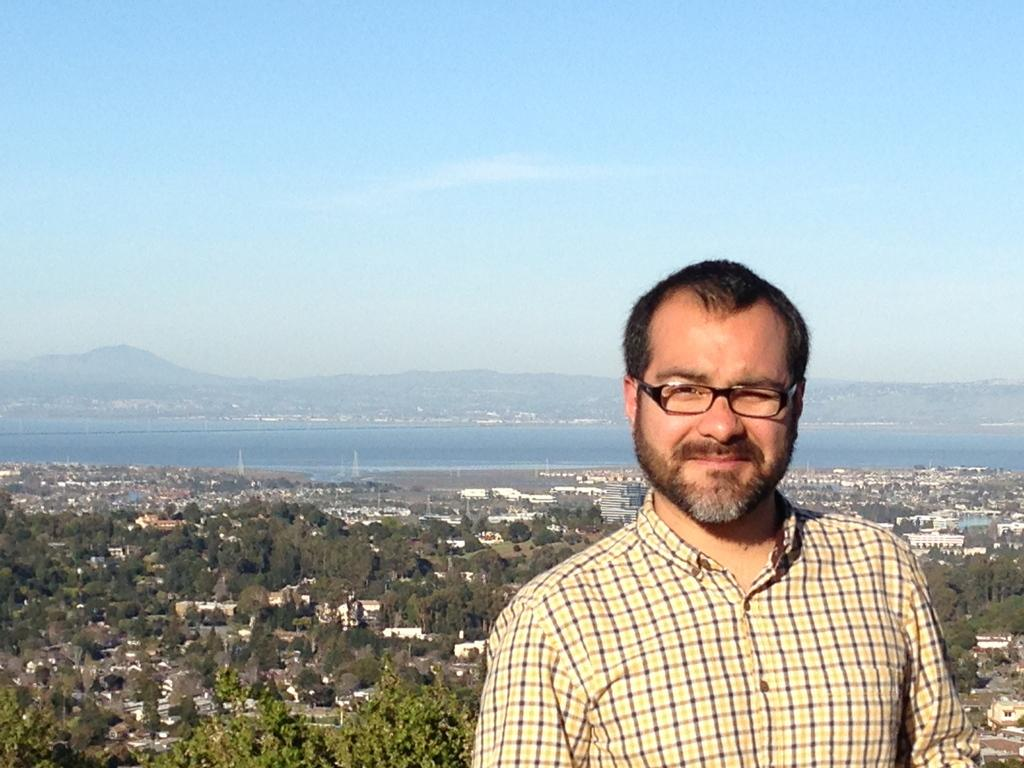Who is the main subject in the image? There is a man in the front of the image. What is the man wearing in the image? The man is wearing spectacles. What can be seen in the background of the image? There are trees, buildings, and water visible in the background of the image. What is visible at the top of the image? The sky is visible at the top of the image. What type of jewel is the man holding in the image? There is no jewel present in the image; the man is not holding anything. How many beads can be seen on the man's necklace in the image? There is no necklace or beads visible in the image. 